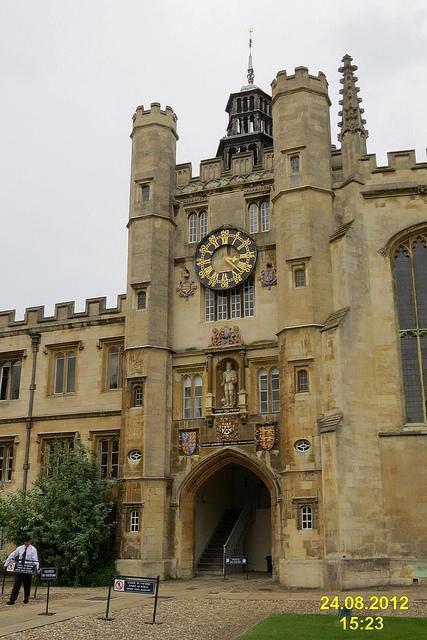What is the person on the left wearing? tie 